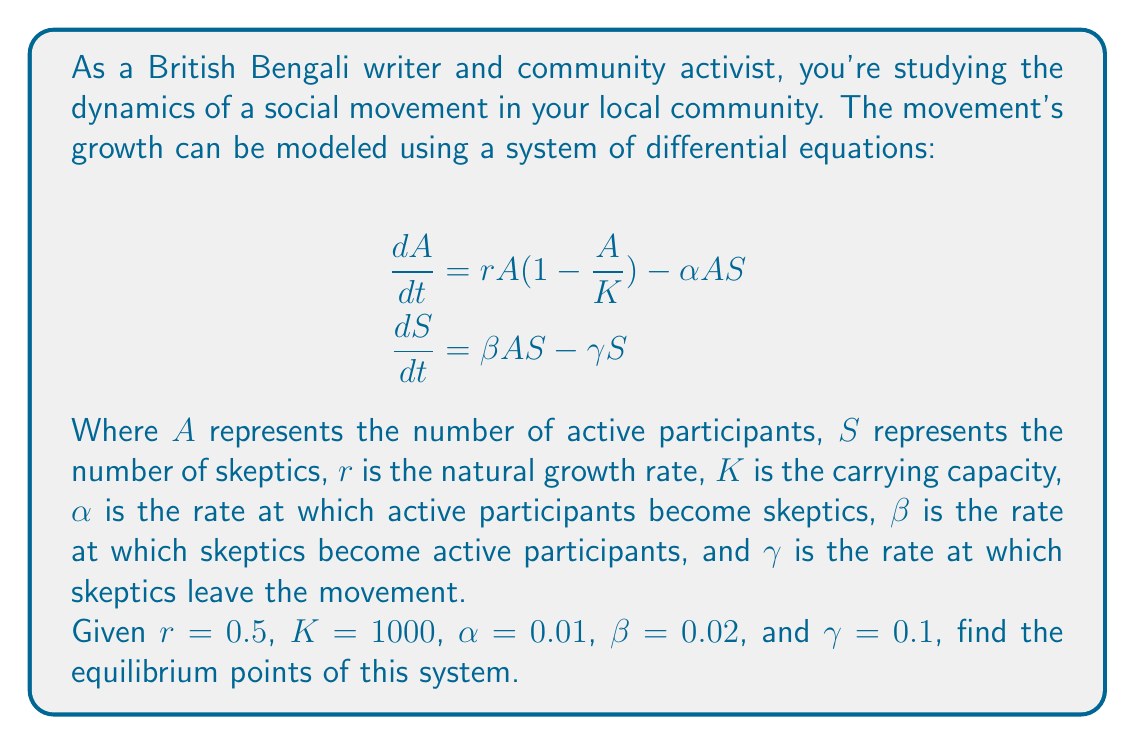Give your solution to this math problem. To find the equilibrium points, we need to set both equations equal to zero and solve for $A$ and $S$:

$$\begin{aligned}
0 &= rA(1-\frac{A}{K}) - \alpha AS \\
0 &= \beta AS - \gamma S
\end{aligned}$$

From the second equation:
$$\beta AS - \gamma S = 0$$
$$S(\beta A - \gamma) = 0$$

This gives us two possibilities:
1) $S = 0$, or
2) $\beta A - \gamma = 0$, which means $A = \frac{\gamma}{\beta}$

Let's consider each case:

1) When $S = 0$:
Substituting into the first equation:
$$0 = rA(1-\frac{A}{K})$$
This gives us $A = 0$ or $A = K$

2) When $A = \frac{\gamma}{\beta}$:
Substituting into the first equation:
$$0 = r\frac{\gamma}{\beta}(1-\frac{\gamma}{\beta K}) - \alpha \frac{\gamma}{\beta}S$$

Solving for $S$:
$$S = \frac{r}{\alpha}(1-\frac{\gamma}{\beta K})$$

Now, let's substitute the given values:
$r = 0.5$, $K = 1000$, $\alpha = 0.01$, $\beta = 0.02$, $\gamma = 0.1$

For case 2:
$$A = \frac{\gamma}{\beta} = \frac{0.1}{0.02} = 5$$
$$S = \frac{r}{\alpha}(1-\frac{\gamma}{\beta K}) = \frac{0.5}{0.01}(1-\frac{0.1}{0.02 \cdot 1000}) = 50(0.995) = 49.75$$

Therefore, we have three equilibrium points:
(0, 0), (1000, 0), and (5, 49.75)
Answer: The equilibrium points are (0, 0), (1000, 0), and (5, 49.75). 